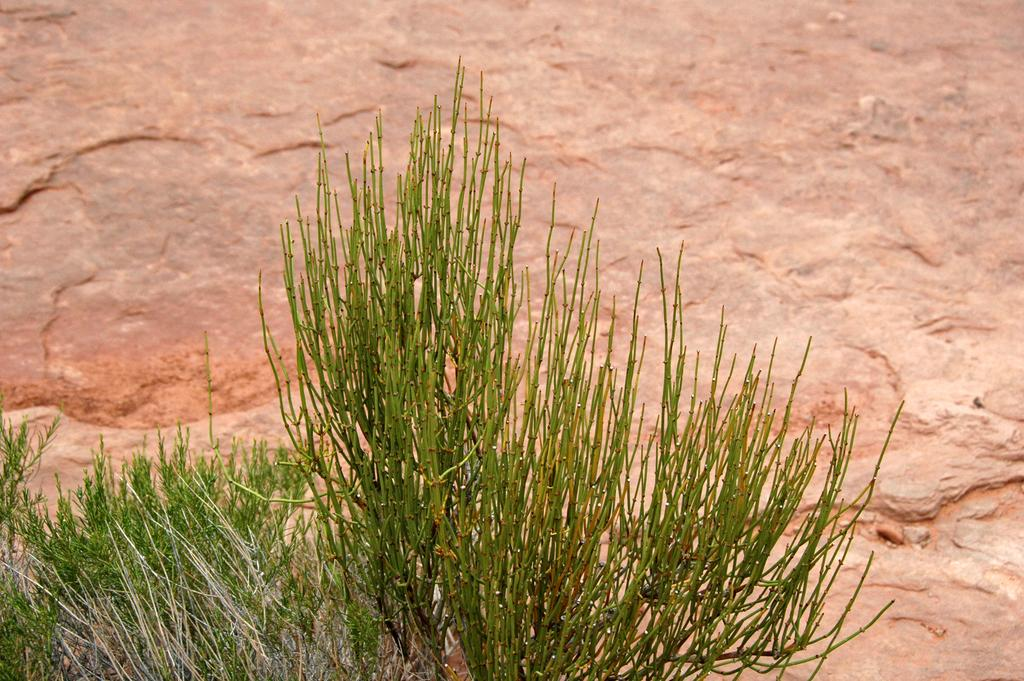What type of living organisms can be seen in the image? Plants can be seen in the image. What large object is visible in the background of the image? There is a huge rock in the background of the image. What type of insurance is being discussed in the image? There is no discussion of insurance in the image; it features plants and a huge rock. What type of sail can be seen in the image? There is no sail present in the image. 